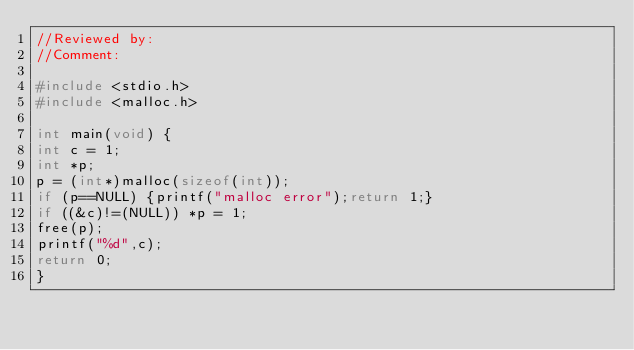Convert code to text. <code><loc_0><loc_0><loc_500><loc_500><_C_>//Reviewed by:
//Comment:

#include <stdio.h>
#include <malloc.h>

int main(void) {
int c = 1;
int *p;
p = (int*)malloc(sizeof(int));
if (p==NULL) {printf("malloc error");return 1;}
if ((&c)!=(NULL)) *p = 1;
free(p);
printf("%d",c);
return 0;
}
</code> 